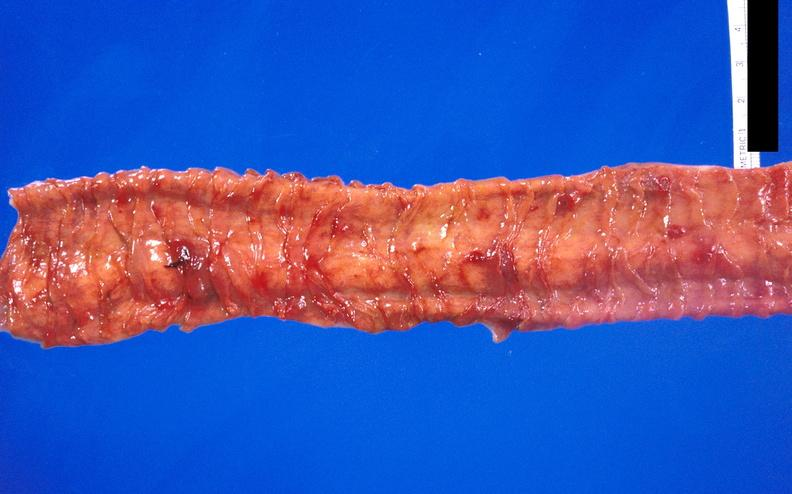s muscle atrophy present?
Answer the question using a single word or phrase. No 